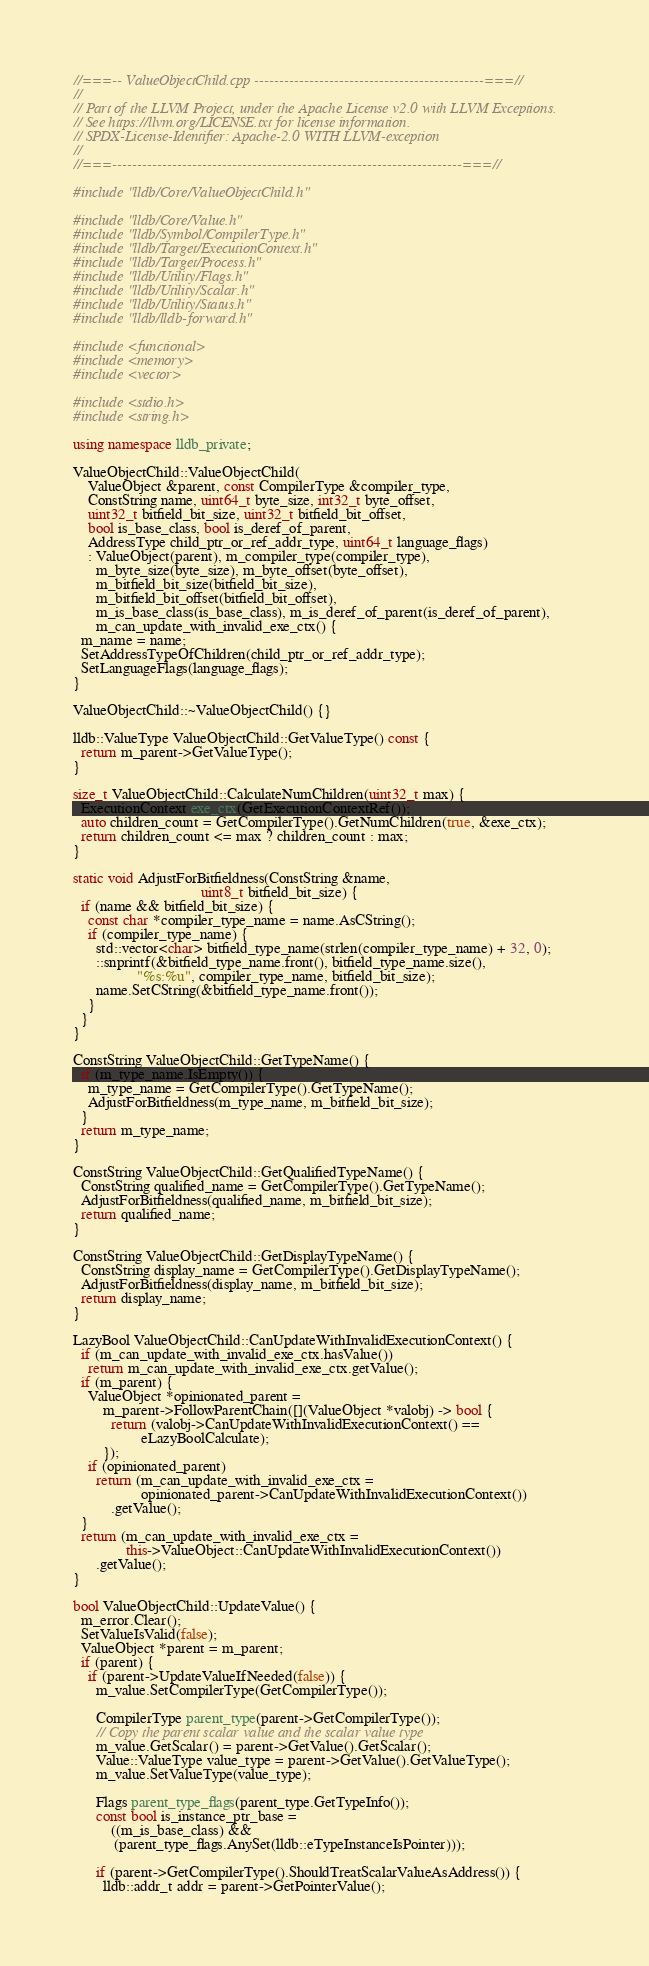Convert code to text. <code><loc_0><loc_0><loc_500><loc_500><_C++_>//===-- ValueObjectChild.cpp ----------------------------------------------===//
//
// Part of the LLVM Project, under the Apache License v2.0 with LLVM Exceptions.
// See https://llvm.org/LICENSE.txt for license information.
// SPDX-License-Identifier: Apache-2.0 WITH LLVM-exception
//
//===----------------------------------------------------------------------===//

#include "lldb/Core/ValueObjectChild.h"

#include "lldb/Core/Value.h"
#include "lldb/Symbol/CompilerType.h"
#include "lldb/Target/ExecutionContext.h"
#include "lldb/Target/Process.h"
#include "lldb/Utility/Flags.h"
#include "lldb/Utility/Scalar.h"
#include "lldb/Utility/Status.h"
#include "lldb/lldb-forward.h"

#include <functional>
#include <memory>
#include <vector>

#include <stdio.h>
#include <string.h>

using namespace lldb_private;

ValueObjectChild::ValueObjectChild(
    ValueObject &parent, const CompilerType &compiler_type,
    ConstString name, uint64_t byte_size, int32_t byte_offset,
    uint32_t bitfield_bit_size, uint32_t bitfield_bit_offset,
    bool is_base_class, bool is_deref_of_parent,
    AddressType child_ptr_or_ref_addr_type, uint64_t language_flags)
    : ValueObject(parent), m_compiler_type(compiler_type),
      m_byte_size(byte_size), m_byte_offset(byte_offset),
      m_bitfield_bit_size(bitfield_bit_size),
      m_bitfield_bit_offset(bitfield_bit_offset),
      m_is_base_class(is_base_class), m_is_deref_of_parent(is_deref_of_parent),
      m_can_update_with_invalid_exe_ctx() {
  m_name = name;
  SetAddressTypeOfChildren(child_ptr_or_ref_addr_type);
  SetLanguageFlags(language_flags);
}

ValueObjectChild::~ValueObjectChild() {}

lldb::ValueType ValueObjectChild::GetValueType() const {
  return m_parent->GetValueType();
}

size_t ValueObjectChild::CalculateNumChildren(uint32_t max) {
  ExecutionContext exe_ctx(GetExecutionContextRef());
  auto children_count = GetCompilerType().GetNumChildren(true, &exe_ctx);
  return children_count <= max ? children_count : max;
}

static void AdjustForBitfieldness(ConstString &name,
                                  uint8_t bitfield_bit_size) {
  if (name && bitfield_bit_size) {
    const char *compiler_type_name = name.AsCString();
    if (compiler_type_name) {
      std::vector<char> bitfield_type_name(strlen(compiler_type_name) + 32, 0);
      ::snprintf(&bitfield_type_name.front(), bitfield_type_name.size(),
                 "%s:%u", compiler_type_name, bitfield_bit_size);
      name.SetCString(&bitfield_type_name.front());
    }
  }
}

ConstString ValueObjectChild::GetTypeName() {
  if (m_type_name.IsEmpty()) {
    m_type_name = GetCompilerType().GetTypeName();
    AdjustForBitfieldness(m_type_name, m_bitfield_bit_size);
  }
  return m_type_name;
}

ConstString ValueObjectChild::GetQualifiedTypeName() {
  ConstString qualified_name = GetCompilerType().GetTypeName();
  AdjustForBitfieldness(qualified_name, m_bitfield_bit_size);
  return qualified_name;
}

ConstString ValueObjectChild::GetDisplayTypeName() {
  ConstString display_name = GetCompilerType().GetDisplayTypeName();
  AdjustForBitfieldness(display_name, m_bitfield_bit_size);
  return display_name;
}

LazyBool ValueObjectChild::CanUpdateWithInvalidExecutionContext() {
  if (m_can_update_with_invalid_exe_ctx.hasValue())
    return m_can_update_with_invalid_exe_ctx.getValue();
  if (m_parent) {
    ValueObject *opinionated_parent =
        m_parent->FollowParentChain([](ValueObject *valobj) -> bool {
          return (valobj->CanUpdateWithInvalidExecutionContext() ==
                  eLazyBoolCalculate);
        });
    if (opinionated_parent)
      return (m_can_update_with_invalid_exe_ctx =
                  opinionated_parent->CanUpdateWithInvalidExecutionContext())
          .getValue();
  }
  return (m_can_update_with_invalid_exe_ctx =
              this->ValueObject::CanUpdateWithInvalidExecutionContext())
      .getValue();
}

bool ValueObjectChild::UpdateValue() {
  m_error.Clear();
  SetValueIsValid(false);
  ValueObject *parent = m_parent;
  if (parent) {
    if (parent->UpdateValueIfNeeded(false)) {
      m_value.SetCompilerType(GetCompilerType());

      CompilerType parent_type(parent->GetCompilerType());
      // Copy the parent scalar value and the scalar value type
      m_value.GetScalar() = parent->GetValue().GetScalar();
      Value::ValueType value_type = parent->GetValue().GetValueType();
      m_value.SetValueType(value_type);

      Flags parent_type_flags(parent_type.GetTypeInfo());
      const bool is_instance_ptr_base =
          ((m_is_base_class) &&
           (parent_type_flags.AnySet(lldb::eTypeInstanceIsPointer)));

      if (parent->GetCompilerType().ShouldTreatScalarValueAsAddress()) {
        lldb::addr_t addr = parent->GetPointerValue();</code> 